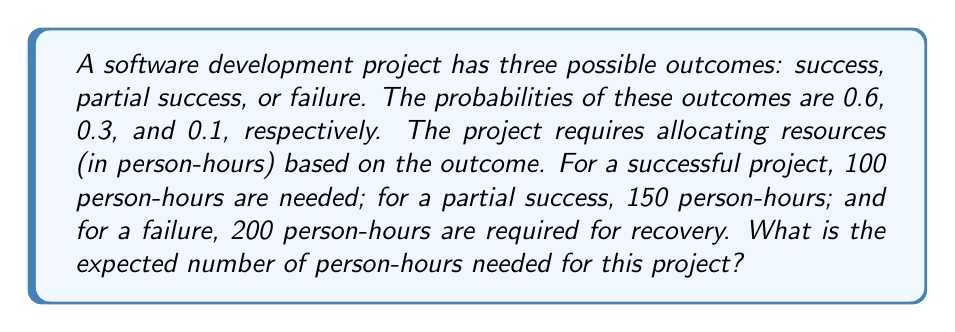Can you answer this question? To solve this problem, we'll use the concept of expected value from probability theory. The steps are as follows:

1. Identify the outcomes and their probabilities:
   - Success: $p_1 = 0.6$
   - Partial success: $p_2 = 0.3$
   - Failure: $p_3 = 0.1$

2. Identify the person-hours required for each outcome:
   - Success: $h_1 = 100$
   - Partial success: $h_2 = 150$
   - Failure: $h_3 = 200$

3. Calculate the expected value using the formula:
   $$E(X) = \sum_{i=1}^n p_i \cdot h_i$$

   Where $E(X)$ is the expected value, $p_i$ is the probability of each outcome, and $h_i$ is the corresponding person-hours.

4. Substitute the values into the formula:
   $$E(X) = (0.6 \cdot 100) + (0.3 \cdot 150) + (0.1 \cdot 200)$$

5. Perform the calculations:
   $$E(X) = 60 + 45 + 20 = 125$$

Therefore, the expected number of person-hours needed for this project is 125.
Answer: 125 person-hours 